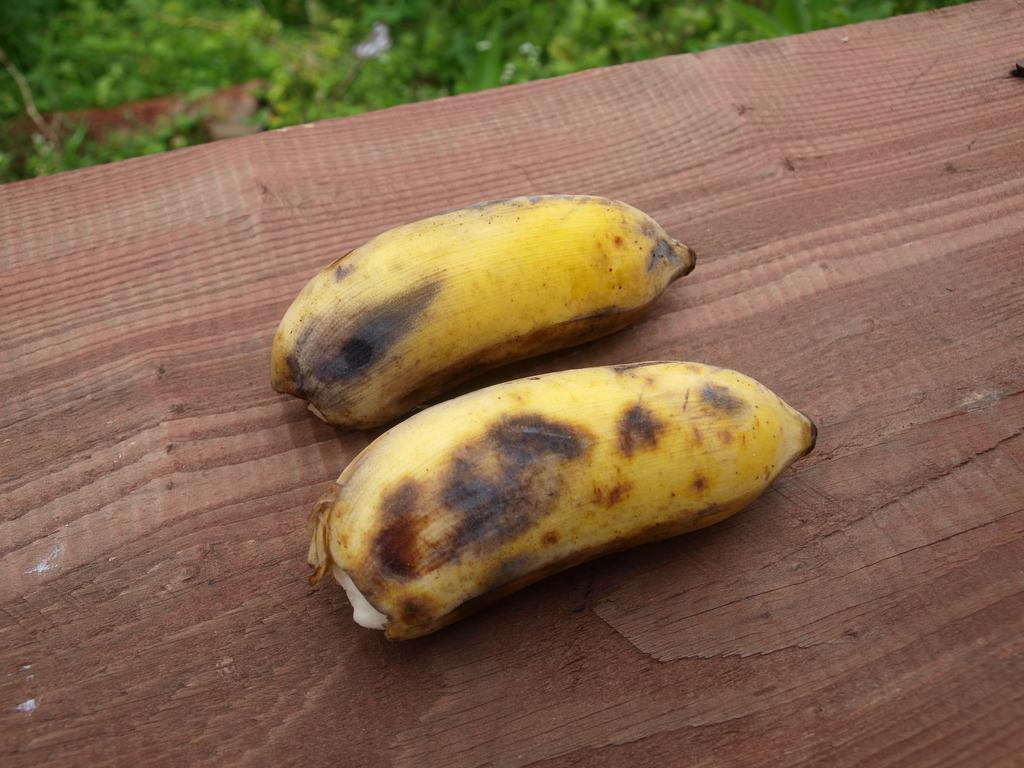What type of fruit is placed on the table in the image? There are bananas placed on a table in the image. What can be seen in the background of the image? There is grass visible in the background of the image. What type of arm is visible in the image? There is no arm visible in the image; it only features bananas on a table and grass in the background. 